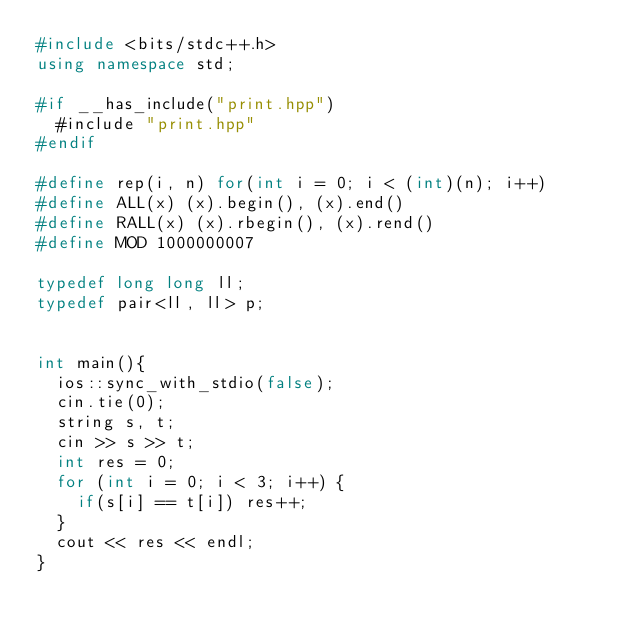<code> <loc_0><loc_0><loc_500><loc_500><_C++_>#include <bits/stdc++.h>
using namespace std;

#if __has_include("print.hpp")
  #include "print.hpp"
#endif

#define rep(i, n) for(int i = 0; i < (int)(n); i++)
#define ALL(x) (x).begin(), (x).end()
#define RALL(x) (x).rbegin(), (x).rend()
#define MOD 1000000007

typedef long long ll;
typedef pair<ll, ll> p;


int main(){
  ios::sync_with_stdio(false);
  cin.tie(0);
  string s, t;
  cin >> s >> t;
  int res = 0;
  for (int i = 0; i < 3; i++) {
    if(s[i] == t[i]) res++;
  }
  cout << res << endl;
}
</code> 